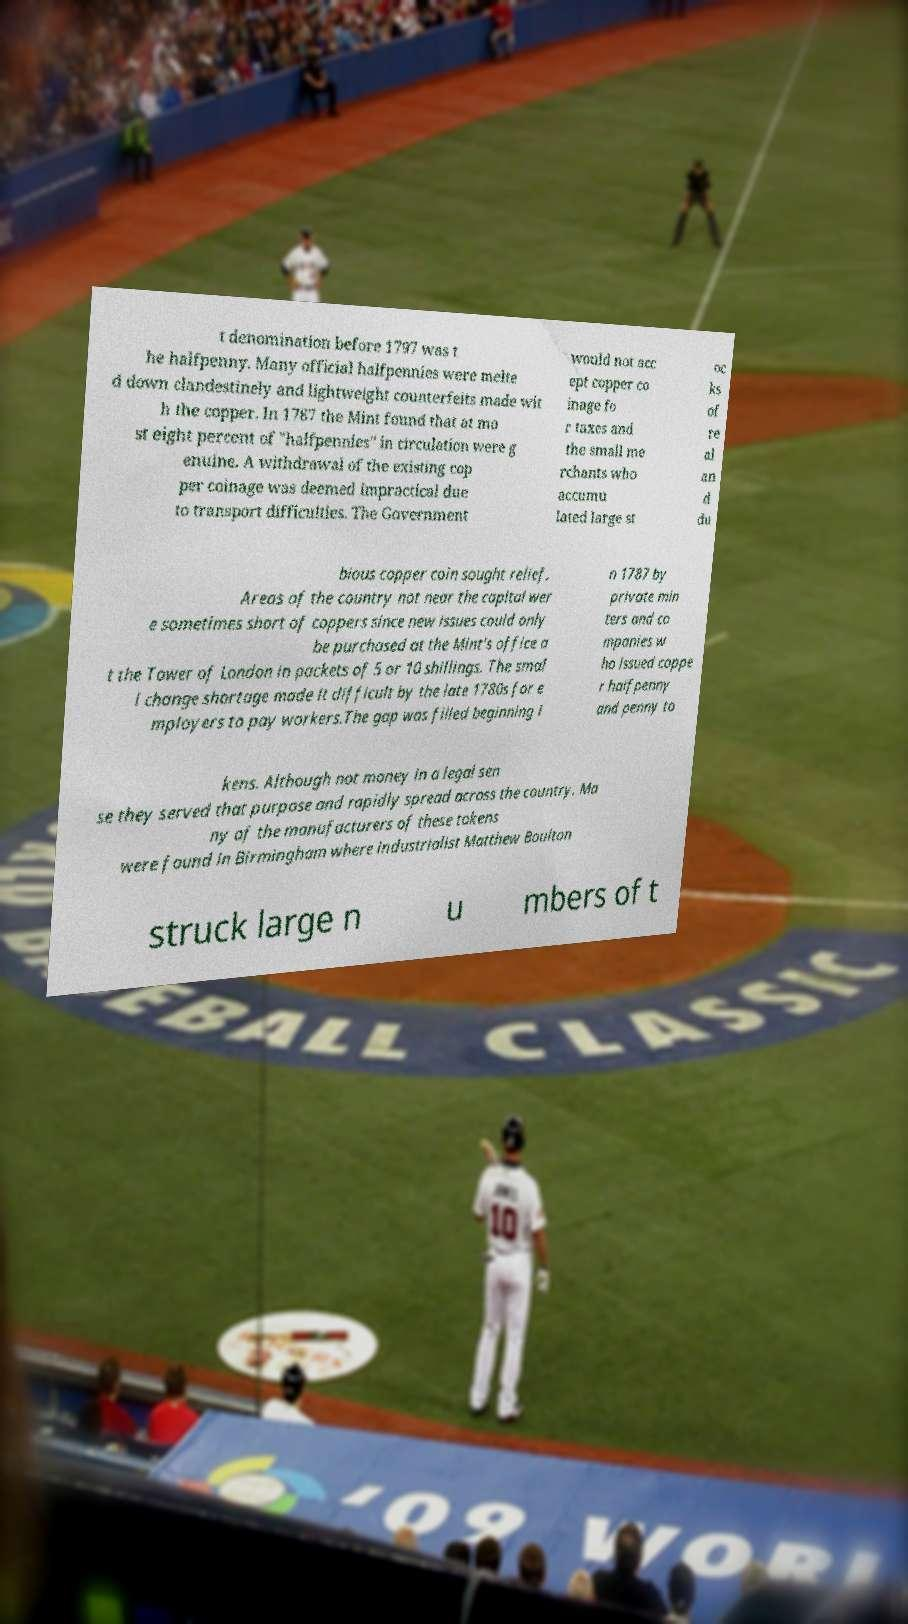Could you extract and type out the text from this image? t denomination before 1797 was t he halfpenny. Many official halfpennies were melte d down clandestinely and lightweight counterfeits made wit h the copper. In 1787 the Mint found that at mo st eight percent of "halfpennies" in circulation were g enuine. A withdrawal of the existing cop per coinage was deemed impractical due to transport difficulties. The Government would not acc ept copper co inage fo r taxes and the small me rchants who accumu lated large st oc ks of re al an d du bious copper coin sought relief. Areas of the country not near the capital wer e sometimes short of coppers since new issues could only be purchased at the Mint's office a t the Tower of London in packets of 5 or 10 shillings. The smal l change shortage made it difficult by the late 1780s for e mployers to pay workers.The gap was filled beginning i n 1787 by private min ters and co mpanies w ho issued coppe r halfpenny and penny to kens. Although not money in a legal sen se they served that purpose and rapidly spread across the country. Ma ny of the manufacturers of these tokens were found in Birmingham where industrialist Matthew Boulton struck large n u mbers of t 